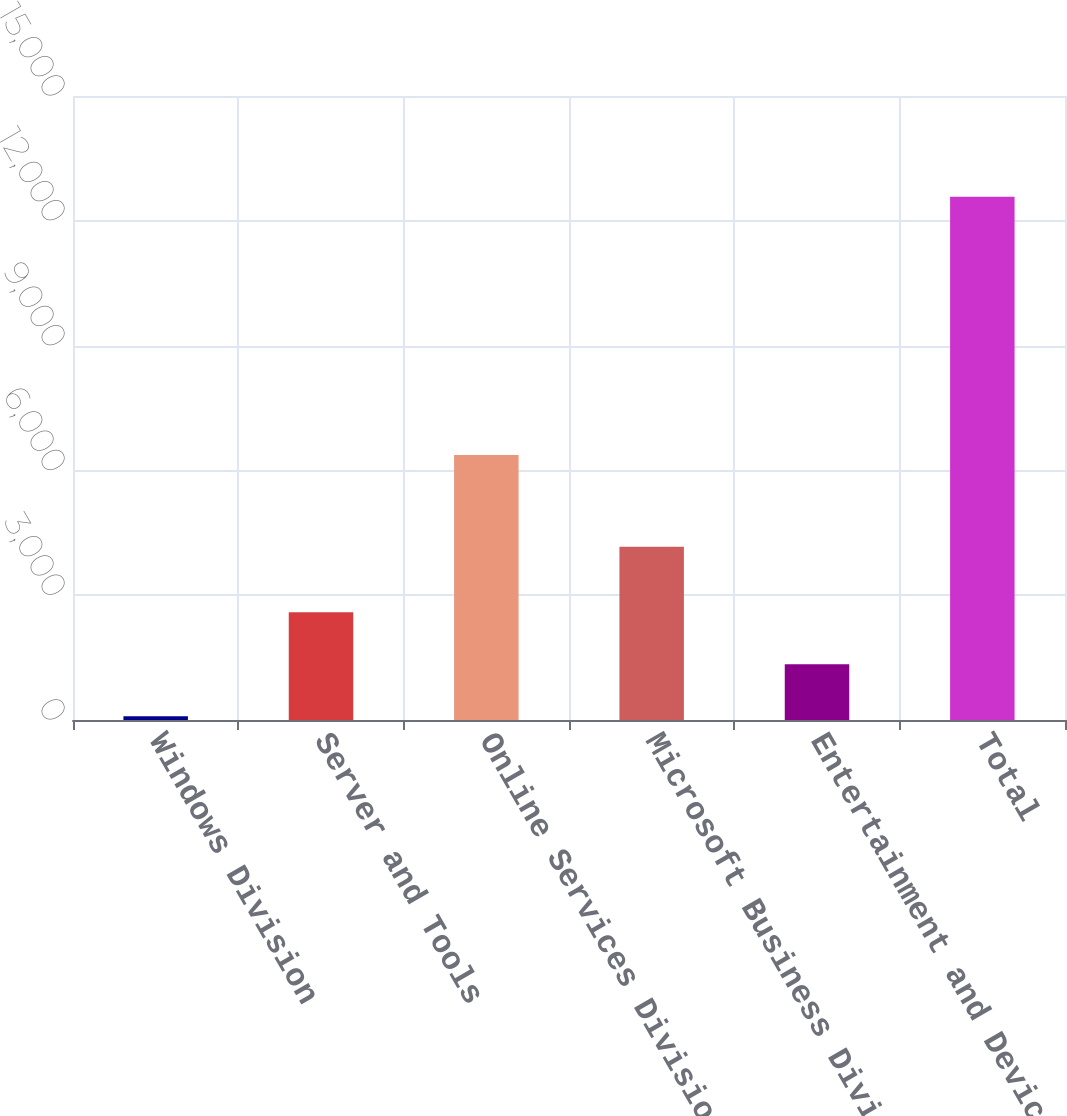<chart> <loc_0><loc_0><loc_500><loc_500><bar_chart><fcel>Windows Division<fcel>Server and Tools<fcel>Online Services Division<fcel>Microsoft Business Division<fcel>Entertainment and Devices<fcel>Total<nl><fcel>89<fcel>2587.4<fcel>6373<fcel>4167<fcel>1338.2<fcel>12581<nl></chart> 